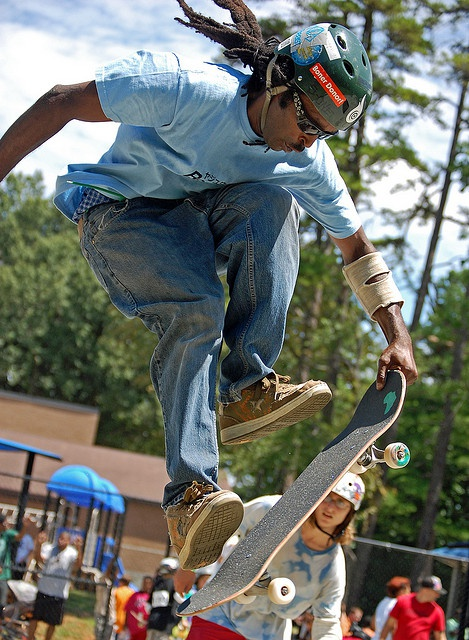Describe the objects in this image and their specific colors. I can see people in lavender, black, gray, and blue tones, people in lavender, darkgray, gray, and white tones, skateboard in lavender, gray, darkgray, and black tones, people in lavender, black, gray, and darkgray tones, and people in lavender, maroon, brown, and red tones in this image. 